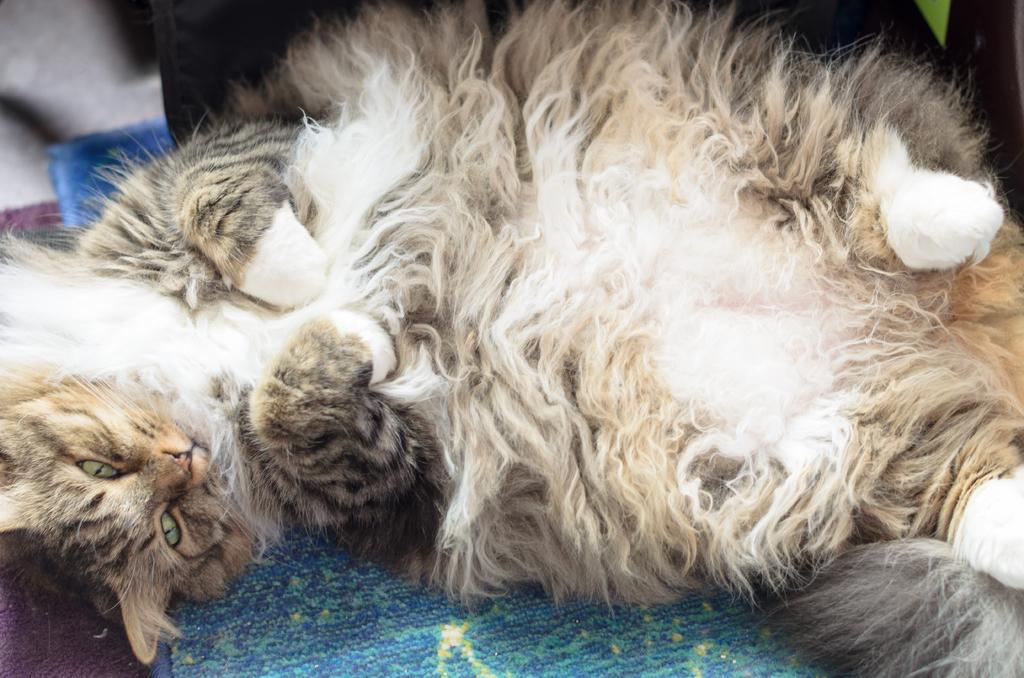What is the main object in the image? There is a cloth in the image. How is the cloth positioned in the image? The cloth is laying on another cloth. What type of expert is providing a sign in the image? There is no expert or sign present in the image; it only features two cloths. How are the cloths being transported in the image? The cloths are not being transported in the image; they are stationary and laying on each other. 